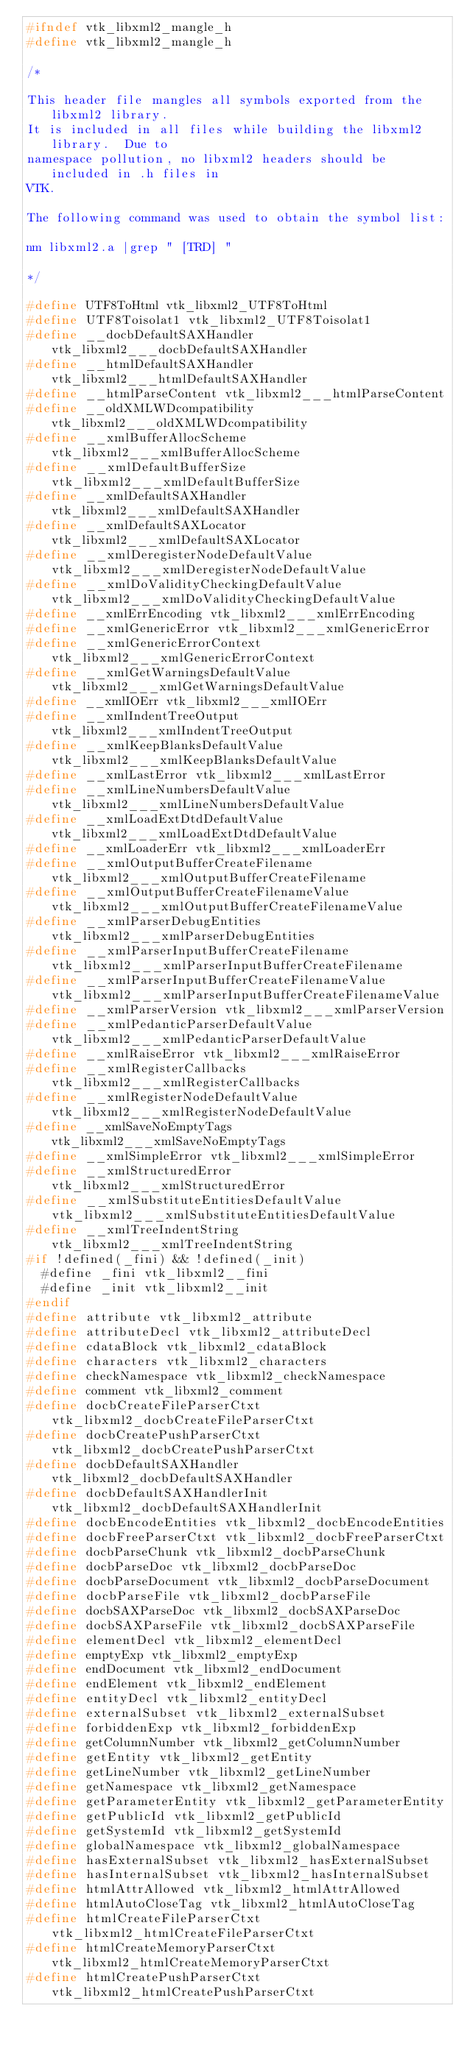<code> <loc_0><loc_0><loc_500><loc_500><_C_>#ifndef vtk_libxml2_mangle_h
#define vtk_libxml2_mangle_h

/*

This header file mangles all symbols exported from the libxml2 library.
It is included in all files while building the libxml2 library.  Due to
namespace pollution, no libxml2 headers should be included in .h files in
VTK.

The following command was used to obtain the symbol list:

nm libxml2.a |grep " [TRD] "

*/

#define UTF8ToHtml vtk_libxml2_UTF8ToHtml
#define UTF8Toisolat1 vtk_libxml2_UTF8Toisolat1
#define __docbDefaultSAXHandler vtk_libxml2___docbDefaultSAXHandler
#define __htmlDefaultSAXHandler vtk_libxml2___htmlDefaultSAXHandler
#define __htmlParseContent vtk_libxml2___htmlParseContent
#define __oldXMLWDcompatibility vtk_libxml2___oldXMLWDcompatibility
#define __xmlBufferAllocScheme vtk_libxml2___xmlBufferAllocScheme
#define __xmlDefaultBufferSize vtk_libxml2___xmlDefaultBufferSize
#define __xmlDefaultSAXHandler vtk_libxml2___xmlDefaultSAXHandler
#define __xmlDefaultSAXLocator vtk_libxml2___xmlDefaultSAXLocator
#define __xmlDeregisterNodeDefaultValue vtk_libxml2___xmlDeregisterNodeDefaultValue
#define __xmlDoValidityCheckingDefaultValue vtk_libxml2___xmlDoValidityCheckingDefaultValue
#define __xmlErrEncoding vtk_libxml2___xmlErrEncoding
#define __xmlGenericError vtk_libxml2___xmlGenericError
#define __xmlGenericErrorContext vtk_libxml2___xmlGenericErrorContext
#define __xmlGetWarningsDefaultValue vtk_libxml2___xmlGetWarningsDefaultValue
#define __xmlIOErr vtk_libxml2___xmlIOErr
#define __xmlIndentTreeOutput vtk_libxml2___xmlIndentTreeOutput
#define __xmlKeepBlanksDefaultValue vtk_libxml2___xmlKeepBlanksDefaultValue
#define __xmlLastError vtk_libxml2___xmlLastError
#define __xmlLineNumbersDefaultValue vtk_libxml2___xmlLineNumbersDefaultValue
#define __xmlLoadExtDtdDefaultValue vtk_libxml2___xmlLoadExtDtdDefaultValue
#define __xmlLoaderErr vtk_libxml2___xmlLoaderErr
#define __xmlOutputBufferCreateFilename vtk_libxml2___xmlOutputBufferCreateFilename
#define __xmlOutputBufferCreateFilenameValue vtk_libxml2___xmlOutputBufferCreateFilenameValue
#define __xmlParserDebugEntities vtk_libxml2___xmlParserDebugEntities
#define __xmlParserInputBufferCreateFilename vtk_libxml2___xmlParserInputBufferCreateFilename
#define __xmlParserInputBufferCreateFilenameValue vtk_libxml2___xmlParserInputBufferCreateFilenameValue
#define __xmlParserVersion vtk_libxml2___xmlParserVersion
#define __xmlPedanticParserDefaultValue vtk_libxml2___xmlPedanticParserDefaultValue
#define __xmlRaiseError vtk_libxml2___xmlRaiseError
#define __xmlRegisterCallbacks vtk_libxml2___xmlRegisterCallbacks
#define __xmlRegisterNodeDefaultValue vtk_libxml2___xmlRegisterNodeDefaultValue
#define __xmlSaveNoEmptyTags vtk_libxml2___xmlSaveNoEmptyTags
#define __xmlSimpleError vtk_libxml2___xmlSimpleError
#define __xmlStructuredError vtk_libxml2___xmlStructuredError
#define __xmlSubstituteEntitiesDefaultValue vtk_libxml2___xmlSubstituteEntitiesDefaultValue
#define __xmlTreeIndentString vtk_libxml2___xmlTreeIndentString
#if !defined(_fini) && !defined(_init)
  #define _fini vtk_libxml2__fini
  #define _init vtk_libxml2__init
#endif
#define attribute vtk_libxml2_attribute
#define attributeDecl vtk_libxml2_attributeDecl
#define cdataBlock vtk_libxml2_cdataBlock
#define characters vtk_libxml2_characters
#define checkNamespace vtk_libxml2_checkNamespace
#define comment vtk_libxml2_comment
#define docbCreateFileParserCtxt vtk_libxml2_docbCreateFileParserCtxt
#define docbCreatePushParserCtxt vtk_libxml2_docbCreatePushParserCtxt
#define docbDefaultSAXHandler vtk_libxml2_docbDefaultSAXHandler
#define docbDefaultSAXHandlerInit vtk_libxml2_docbDefaultSAXHandlerInit
#define docbEncodeEntities vtk_libxml2_docbEncodeEntities
#define docbFreeParserCtxt vtk_libxml2_docbFreeParserCtxt
#define docbParseChunk vtk_libxml2_docbParseChunk
#define docbParseDoc vtk_libxml2_docbParseDoc
#define docbParseDocument vtk_libxml2_docbParseDocument
#define docbParseFile vtk_libxml2_docbParseFile
#define docbSAXParseDoc vtk_libxml2_docbSAXParseDoc
#define docbSAXParseFile vtk_libxml2_docbSAXParseFile
#define elementDecl vtk_libxml2_elementDecl
#define emptyExp vtk_libxml2_emptyExp
#define endDocument vtk_libxml2_endDocument
#define endElement vtk_libxml2_endElement
#define entityDecl vtk_libxml2_entityDecl
#define externalSubset vtk_libxml2_externalSubset
#define forbiddenExp vtk_libxml2_forbiddenExp
#define getColumnNumber vtk_libxml2_getColumnNumber
#define getEntity vtk_libxml2_getEntity
#define getLineNumber vtk_libxml2_getLineNumber
#define getNamespace vtk_libxml2_getNamespace
#define getParameterEntity vtk_libxml2_getParameterEntity
#define getPublicId vtk_libxml2_getPublicId
#define getSystemId vtk_libxml2_getSystemId
#define globalNamespace vtk_libxml2_globalNamespace
#define hasExternalSubset vtk_libxml2_hasExternalSubset
#define hasInternalSubset vtk_libxml2_hasInternalSubset
#define htmlAttrAllowed vtk_libxml2_htmlAttrAllowed
#define htmlAutoCloseTag vtk_libxml2_htmlAutoCloseTag
#define htmlCreateFileParserCtxt vtk_libxml2_htmlCreateFileParserCtxt
#define htmlCreateMemoryParserCtxt vtk_libxml2_htmlCreateMemoryParserCtxt
#define htmlCreatePushParserCtxt vtk_libxml2_htmlCreatePushParserCtxt</code> 